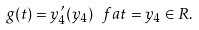Convert formula to latex. <formula><loc_0><loc_0><loc_500><loc_500>g ( t ) = y ^ { \prime } _ { 4 } ( y _ { 4 } ) \ f a t = y _ { 4 } \in R .</formula> 